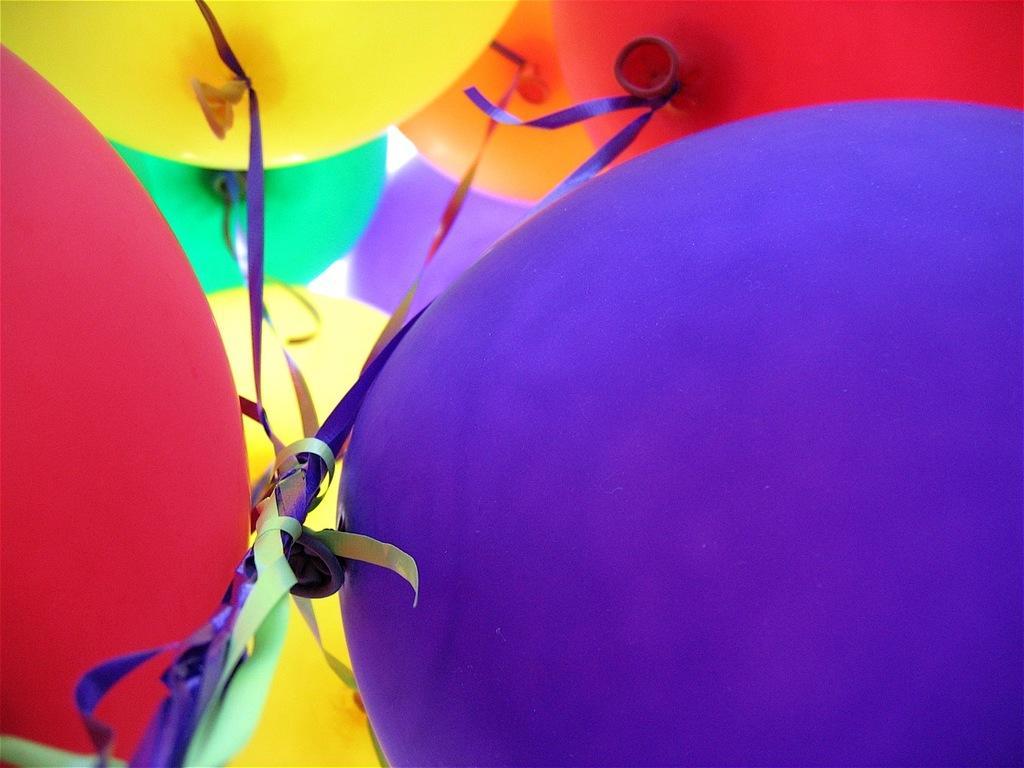Please provide a concise description of this image. In this picture we can see balloons of different colors such as yellow, green, red, orange, blue and ribbons tied to them. 